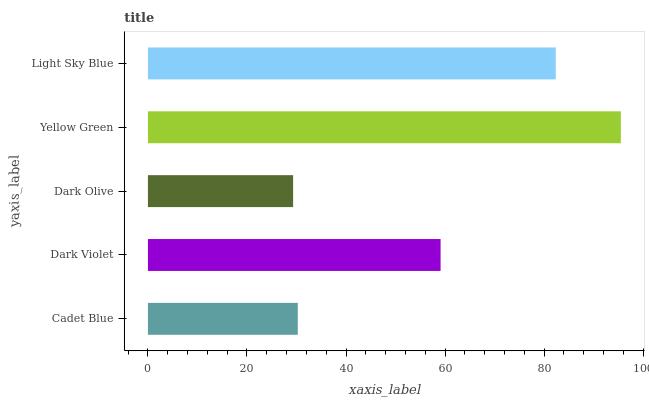Is Dark Olive the minimum?
Answer yes or no. Yes. Is Yellow Green the maximum?
Answer yes or no. Yes. Is Dark Violet the minimum?
Answer yes or no. No. Is Dark Violet the maximum?
Answer yes or no. No. Is Dark Violet greater than Cadet Blue?
Answer yes or no. Yes. Is Cadet Blue less than Dark Violet?
Answer yes or no. Yes. Is Cadet Blue greater than Dark Violet?
Answer yes or no. No. Is Dark Violet less than Cadet Blue?
Answer yes or no. No. Is Dark Violet the high median?
Answer yes or no. Yes. Is Dark Violet the low median?
Answer yes or no. Yes. Is Yellow Green the high median?
Answer yes or no. No. Is Dark Olive the low median?
Answer yes or no. No. 